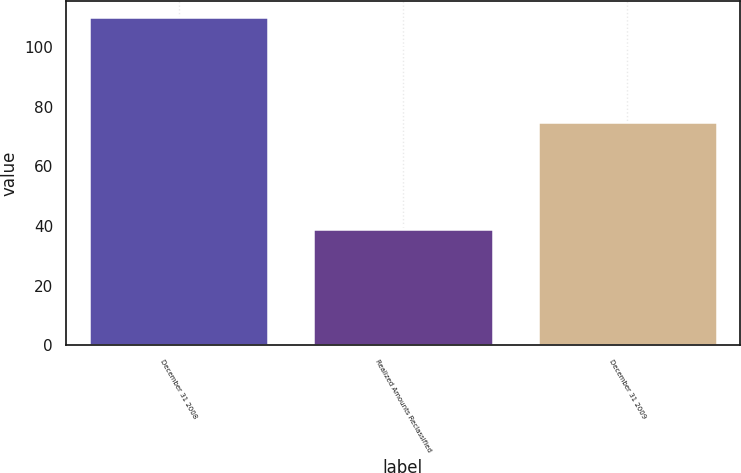Convert chart to OTSL. <chart><loc_0><loc_0><loc_500><loc_500><bar_chart><fcel>December 31 2008<fcel>Realized Amounts Reclassified<fcel>December 31 2009<nl><fcel>110<fcel>39<fcel>75<nl></chart> 